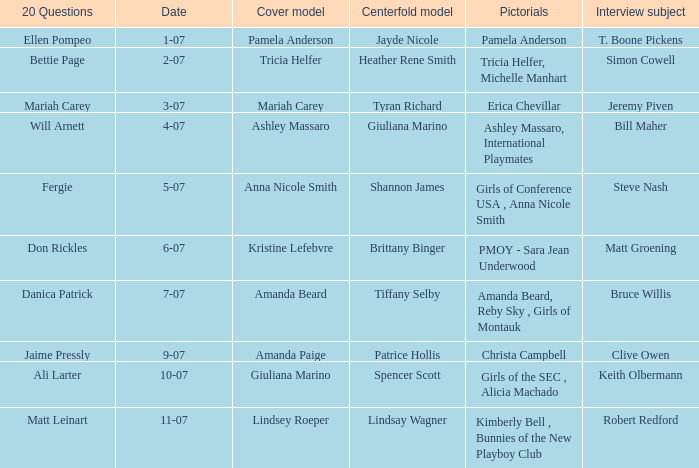List the pictorals from issues when lindsey roeper was the cover model. Kimberly Bell , Bunnies of the New Playboy Club. 